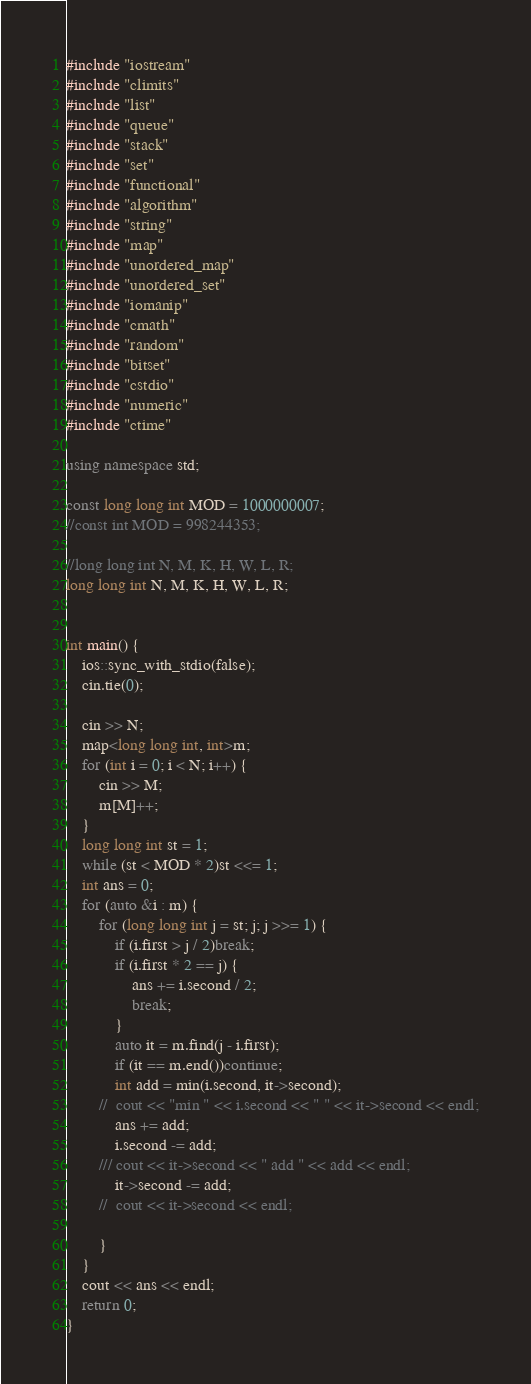Convert code to text. <code><loc_0><loc_0><loc_500><loc_500><_C++_>#include "iostream"
#include "climits"
#include "list"
#include "queue"
#include "stack"
#include "set"
#include "functional"
#include "algorithm"
#include "string"
#include "map"
#include "unordered_map"
#include "unordered_set"
#include "iomanip"
#include "cmath"
#include "random"
#include "bitset"
#include "cstdio"
#include "numeric"
#include "ctime"

using namespace std;

const long long int MOD = 1000000007;
//const int MOD = 998244353;

//long long int N, M, K, H, W, L, R;
long long int N, M, K, H, W, L, R;


int main() {
	ios::sync_with_stdio(false);
	cin.tie(0);

	cin >> N;
	map<long long int, int>m;
	for (int i = 0; i < N; i++) {
		cin >> M;
		m[M]++;
	}
	long long int st = 1;
	while (st < MOD * 2)st <<= 1;
	int ans = 0;
	for (auto &i : m) {
		for (long long int j = st; j; j >>= 1) {
			if (i.first > j / 2)break;
			if (i.first * 2 == j) {
				ans += i.second / 2;
				break;
			}
			auto it = m.find(j - i.first);
			if (it == m.end())continue;
			int add = min(i.second, it->second);
		//	cout << "min " << i.second << " " << it->second << endl;
			ans += add;
			i.second -= add;
		///	cout << it->second << " add " << add << endl;
			it->second -= add;
		//	cout << it->second << endl;

		}
	}
	cout << ans << endl;
	return 0;
}
</code> 